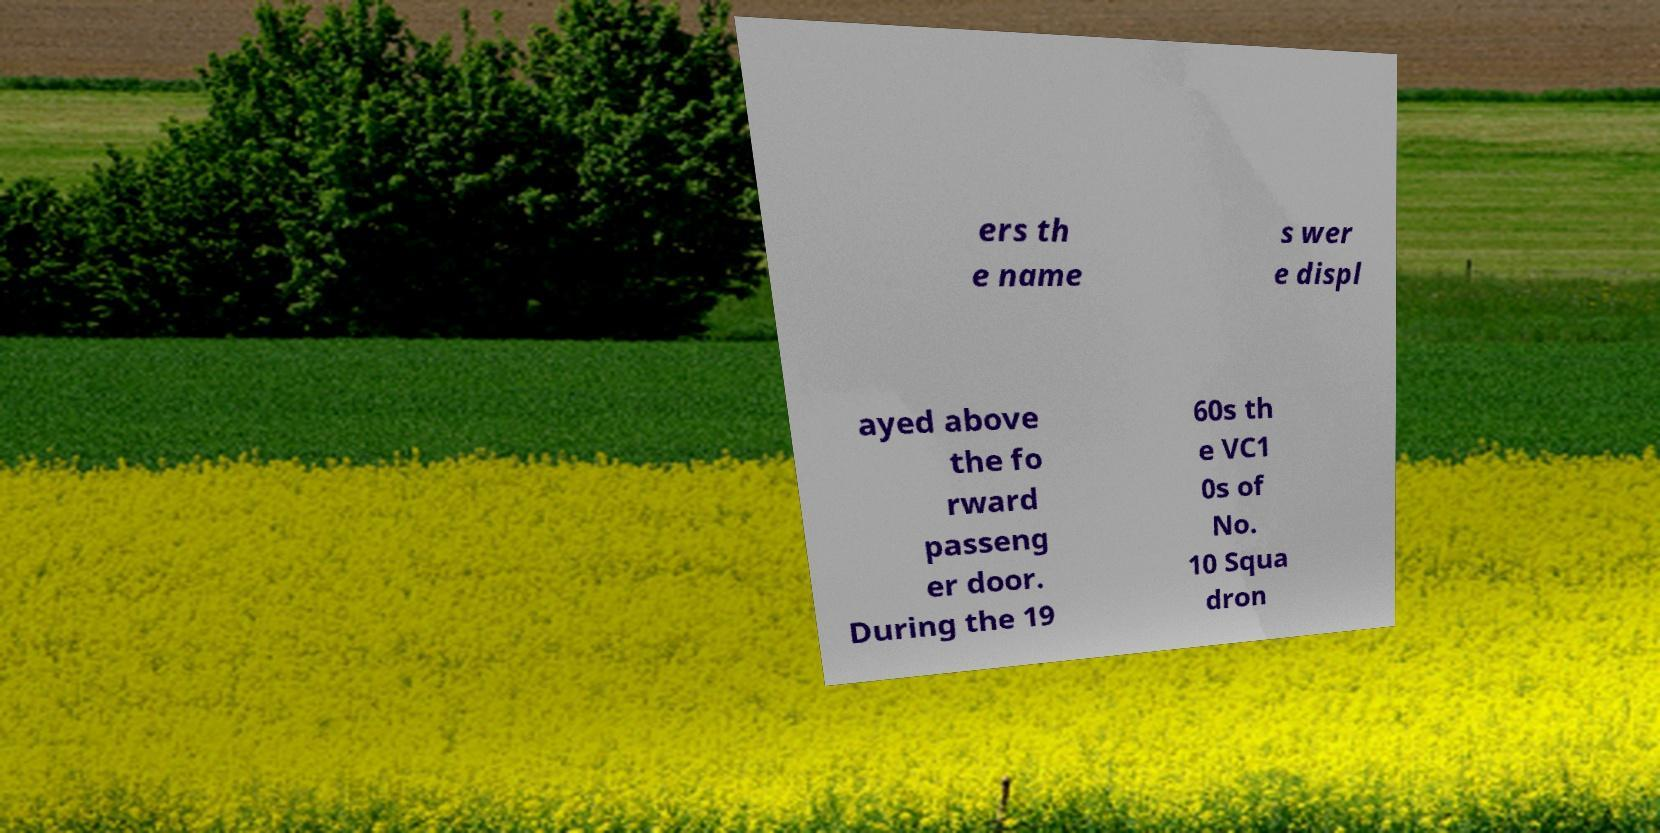Could you assist in decoding the text presented in this image and type it out clearly? ers th e name s wer e displ ayed above the fo rward passeng er door. During the 19 60s th e VC1 0s of No. 10 Squa dron 